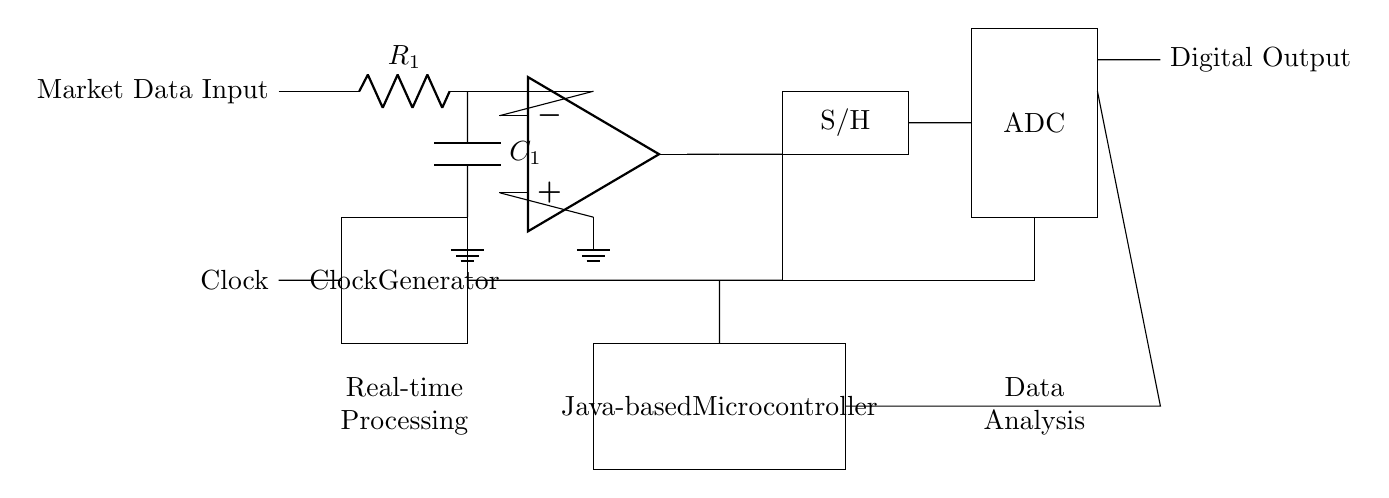What is the type of input for this circuit? The input is labeled as "Market Data Input," which indicates that the circuit is processing analog market data signals.
Answer: Market Data Input What component is responsible for sampling in this circuit? The "S/H" label indicates the component that is responsible for sampling and holding the analog signal at a constant value for processing.
Answer: S/H What follows the operational amplifier in this circuit? The next component after the operational amplifier, indicated by a line going from it, is the sample and hold circuit before digital conversion.
Answer: Sample and Hold What is the main function of the ADC in this circuit? The ADC (Analog-to-Digital Converter) converts the analog signal received from the sample and hold circuit into a digital format for processing.
Answer: Conversion How is the clock signal generated in this circuit? The clock signal is generated by the "Clock Generator" component, which is a necessary part of synchronizing the data sampling and processing.
Answer: Clock Generator What type of microcontroller is used in the circuit? The circuit states it utilizes a "Java-based Microcontroller," indicating the software environment it is designed to operate in.
Answer: Java-based Microcontroller What is the purpose of the resistor and capacitor labeled as R1 and C1? R1 and C1 form a filter network that conditions the market data input signal before it reaches the operational amplifier, ensuring signal integrity and stability.
Answer: Filter Network 